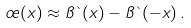Convert formula to latex. <formula><loc_0><loc_0><loc_500><loc_500>\sigma ( x ) \approx \pi \theta ( x ) - \pi \theta ( - x ) \, .</formula> 